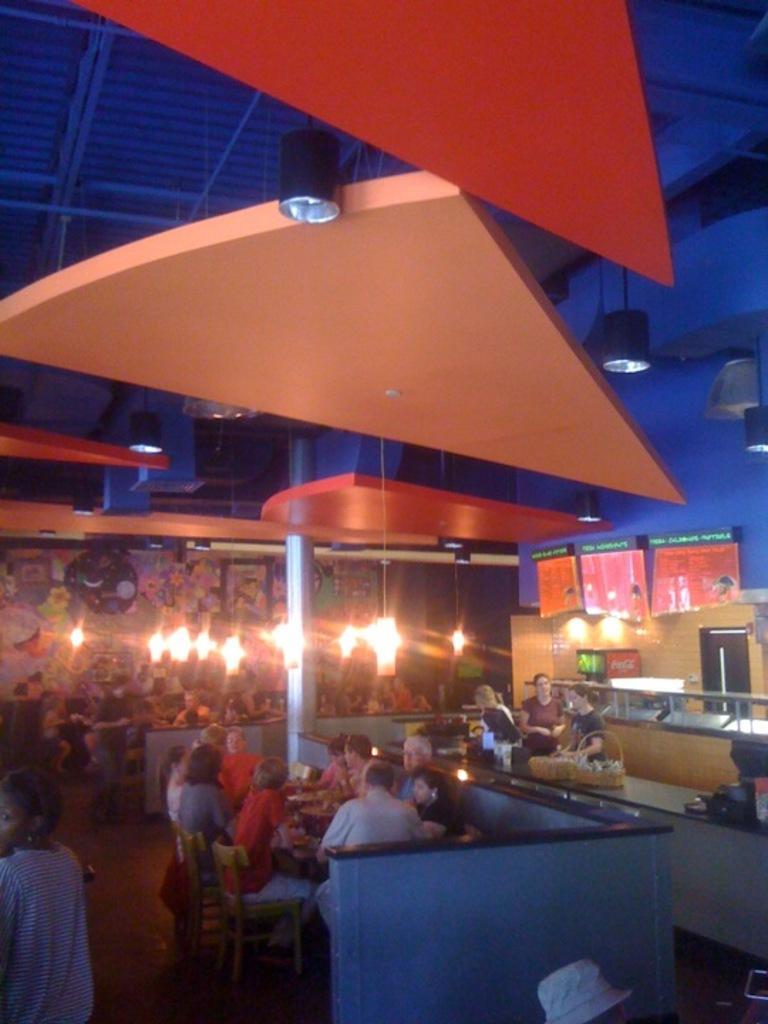In one or two sentences, can you explain what this image depicts? There are people sitting on chairs and we can see pole. These people are standing and we can see buckets and objects on the surface. In the background we can see people,lights and painting on the wall. At the top we can see lights. 